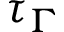<formula> <loc_0><loc_0><loc_500><loc_500>\tau _ { \Gamma }</formula> 